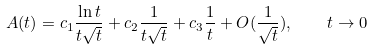Convert formula to latex. <formula><loc_0><loc_0><loc_500><loc_500>A ( t ) = c _ { 1 } \frac { \ln t } { t \sqrt { t } } + c _ { 2 } \frac { 1 } { t \sqrt { t } } + c _ { 3 } \frac { 1 } { t } + O ( \frac { 1 } { \sqrt { t } } ) , \quad t \rightarrow 0</formula> 